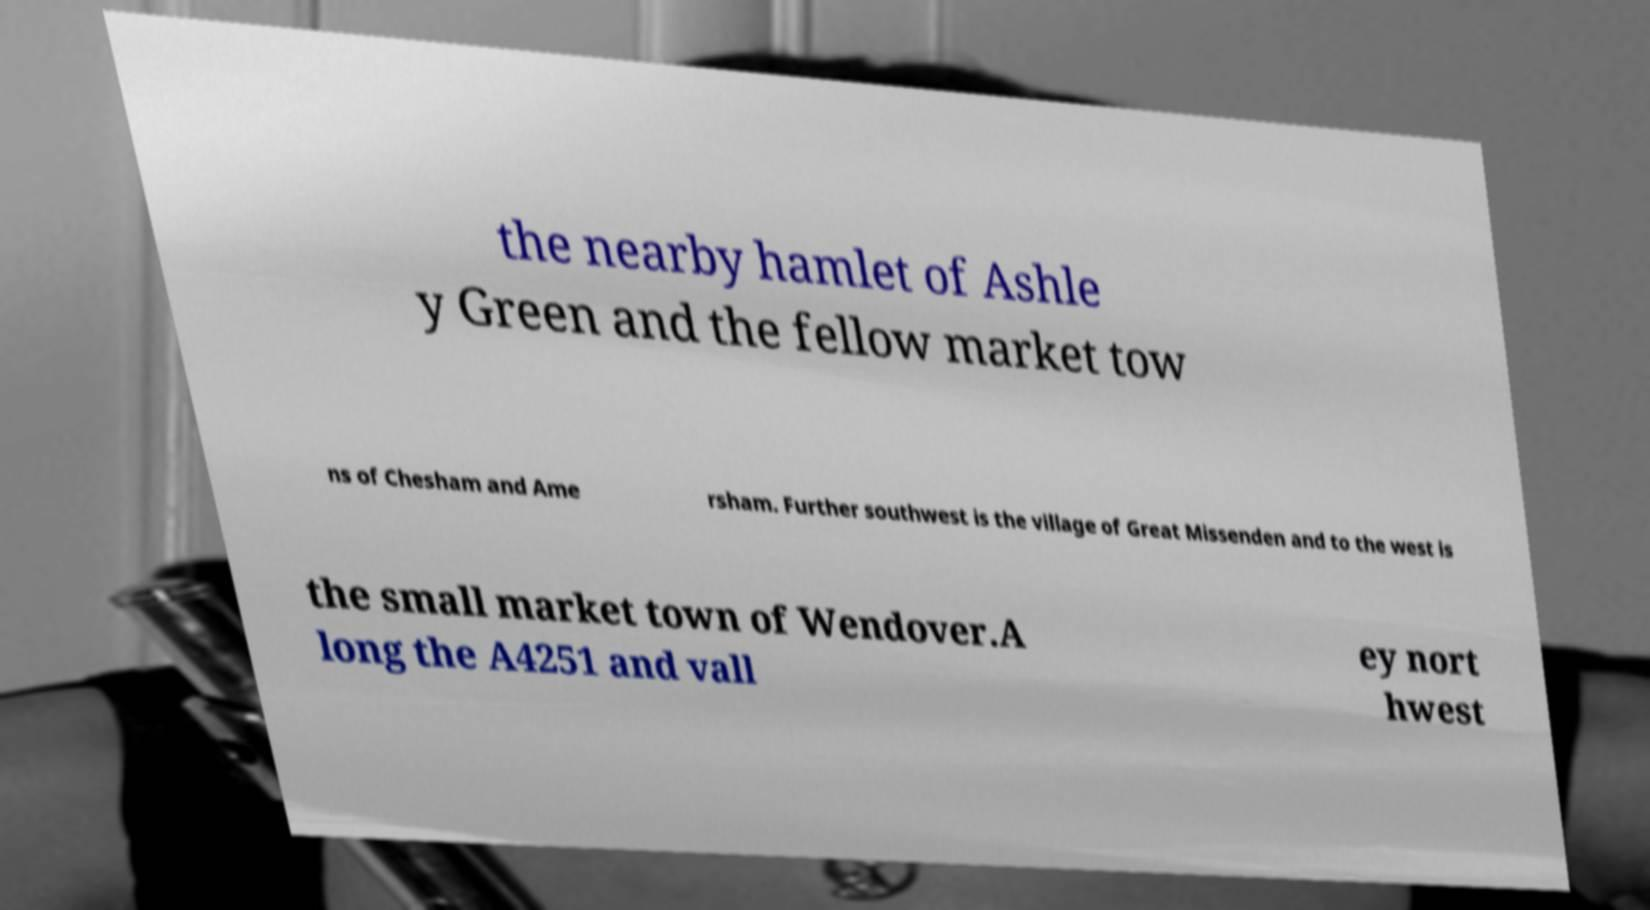I need the written content from this picture converted into text. Can you do that? the nearby hamlet of Ashle y Green and the fellow market tow ns of Chesham and Ame rsham. Further southwest is the village of Great Missenden and to the west is the small market town of Wendover.A long the A4251 and vall ey nort hwest 